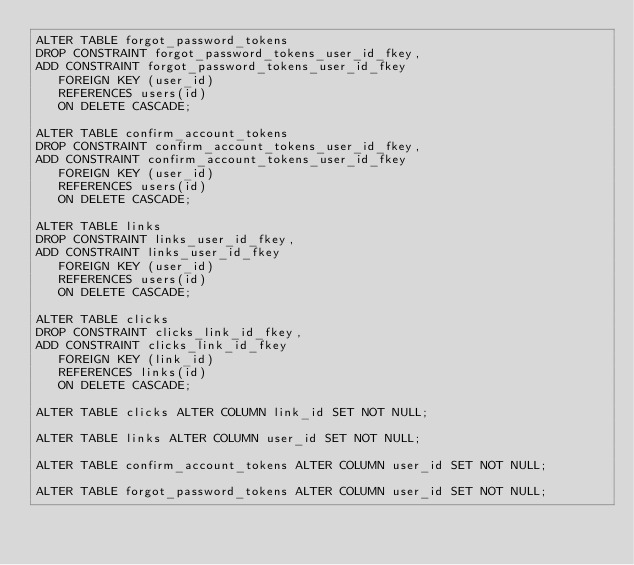Convert code to text. <code><loc_0><loc_0><loc_500><loc_500><_SQL_>ALTER TABLE forgot_password_tokens
DROP CONSTRAINT forgot_password_tokens_user_id_fkey,
ADD CONSTRAINT forgot_password_tokens_user_id_fkey
   FOREIGN KEY (user_id)
   REFERENCES users(id)
   ON DELETE CASCADE;

ALTER TABLE confirm_account_tokens
DROP CONSTRAINT confirm_account_tokens_user_id_fkey,
ADD CONSTRAINT confirm_account_tokens_user_id_fkey
   FOREIGN KEY (user_id)
   REFERENCES users(id)
   ON DELETE CASCADE;

ALTER TABLE links
DROP CONSTRAINT links_user_id_fkey,
ADD CONSTRAINT links_user_id_fkey
   FOREIGN KEY (user_id)
   REFERENCES users(id)
   ON DELETE CASCADE;

ALTER TABLE clicks
DROP CONSTRAINT clicks_link_id_fkey,
ADD CONSTRAINT clicks_link_id_fkey
   FOREIGN KEY (link_id)
   REFERENCES links(id)
   ON DELETE CASCADE;

ALTER TABLE clicks ALTER COLUMN link_id SET NOT NULL;

ALTER TABLE links ALTER COLUMN user_id SET NOT NULL;

ALTER TABLE confirm_account_tokens ALTER COLUMN user_id SET NOT NULL;

ALTER TABLE forgot_password_tokens ALTER COLUMN user_id SET NOT NULL;</code> 